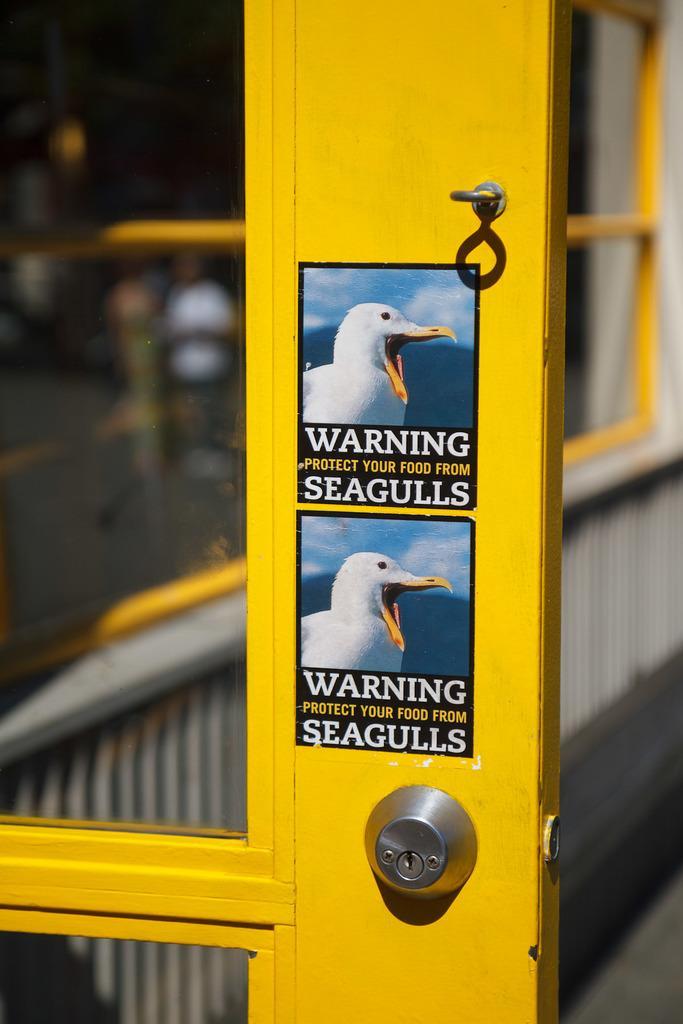Please provide a concise description of this image. In the image we can see there is a door and there are two posters pasted on the door. There is a picture of a bird and its written ¨WARNING SEAGULLS¨ on the poster. Background of the image is little blurred. 